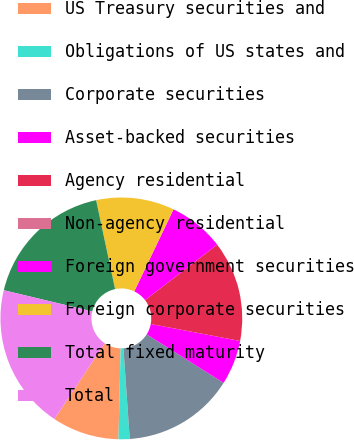Convert chart. <chart><loc_0><loc_0><loc_500><loc_500><pie_chart><fcel>US Treasury securities and<fcel>Obligations of US states and<fcel>Corporate securities<fcel>Asset-backed securities<fcel>Agency residential<fcel>Non-agency residential<fcel>Foreign government securities<fcel>Foreign corporate securities<fcel>Total fixed maturity<fcel>Total<nl><fcel>8.96%<fcel>1.49%<fcel>14.93%<fcel>5.97%<fcel>13.43%<fcel>0.0%<fcel>7.46%<fcel>10.45%<fcel>17.91%<fcel>19.4%<nl></chart> 